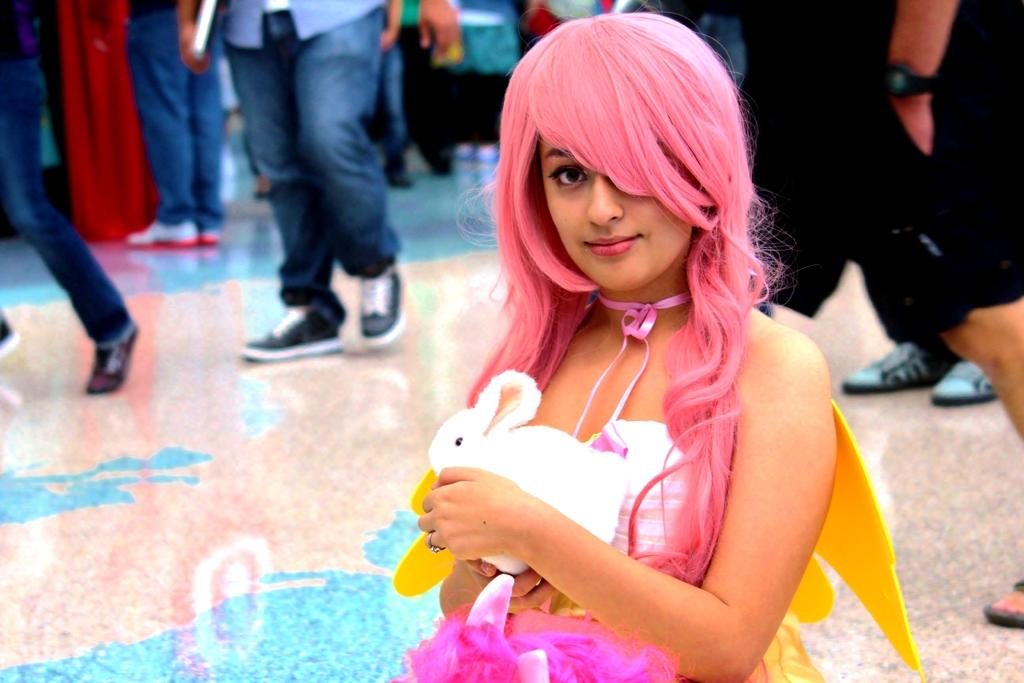Who is the main subject in the image? There is a girl in the image. What is unique about the girl's appearance? The girl has pink hair. What is the girl wearing? The girl is wearing a dress with white, yellow, and pink colors. What is the girl holding in her hand? The girl is holding a rabbit in her hand. What can be seen in the background of the image? There are people walking in the background of the image. What type of button is the girl using to care for the rabbit in the image? There is no button present in the image, and the girl is not using any button to care for the rabbit. 